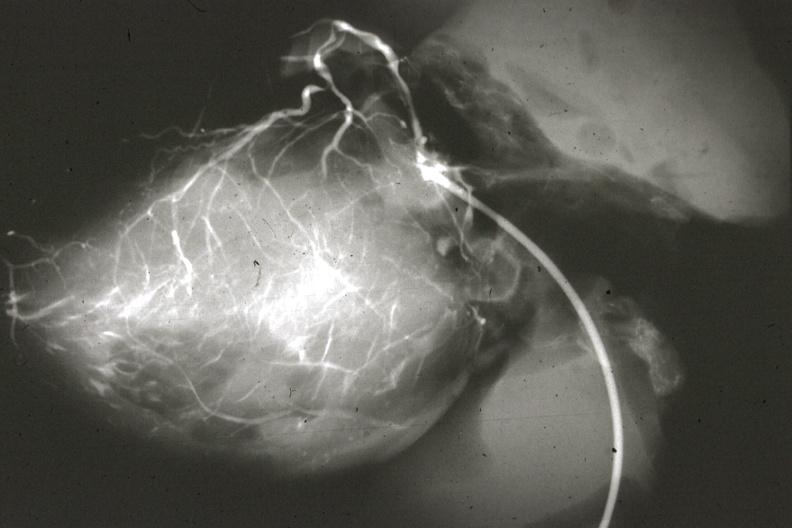what is present?
Answer the question using a single word or phrase. Coronary artery anomalous origin left from pulmonary artery 